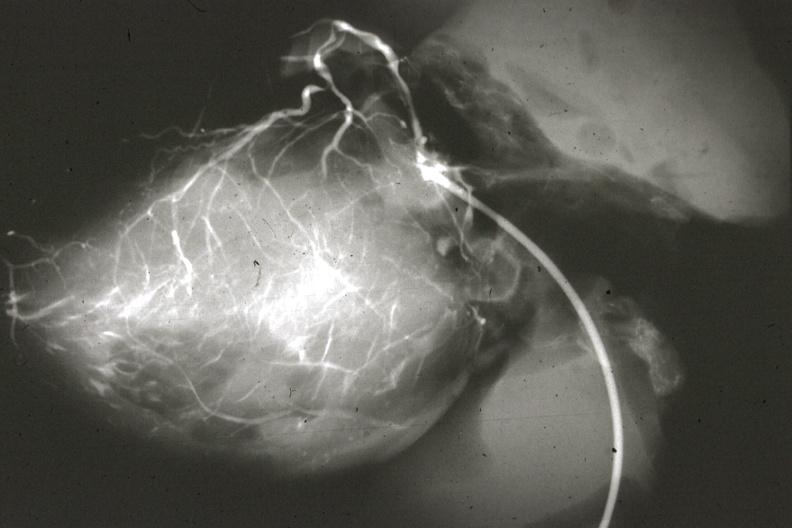what is present?
Answer the question using a single word or phrase. Coronary artery anomalous origin left from pulmonary artery 